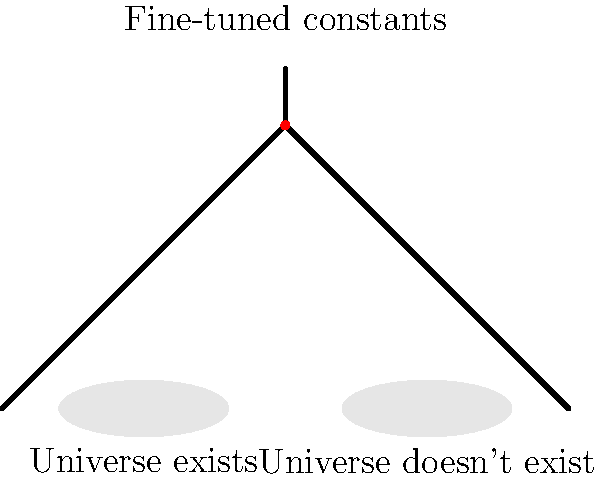In the context of the fine-tuning argument for the existence of a creator, what does the balance point in the cosmic scale represent, and how does it relate to the anthropic principle? To understand this question, let's break it down step-by-step:

1. The fine-tuning argument:
   This argument suggests that the fundamental physical constants of the universe are precisely set to allow for the existence of life. If these constants were slightly different, the universe as we know it wouldn't exist.

2. The cosmic balance scale:
   In the image, the balance scale represents the delicate nature of these physical constants. The left side represents a universe that can support life, while the right side represents a universe that cannot.

3. The balance point:
   The red dot at the fulcrum of the scale represents the exact values of physical constants that allow our universe to exist. This point symbolizes the precise "tuning" of these constants.

4. Relation to the anthropic principle:
   The anthropic principle states that we observe a universe capable of supporting life because we exist to observe it. This principle can be interpreted in two ways:
   a) Weak anthropic principle: Out of many possible universes, we naturally find ourselves in one that can support life.
   b) Strong anthropic principle: The universe is somehow compelled to have conditions that allow life to develop.

5. Creationist perspective:
   From a creationist viewpoint, the precise balance point could be seen as evidence of intelligent design. The fact that the constants are so finely tuned might suggest a creator who intentionally set these values to allow for life.

6. Scientific perspective:
   Scientists might argue that the apparent fine-tuning could be explained by the existence of multiple universes (multiverse theory) or by yet-undiscovered physical laws that necessitate these values.

The balance point in this cosmic scale, therefore, represents the precise values of physical constants that allow for our universe's existence, serving as a focal point for debates between creationist and scientific viewpoints on the origin and nature of the universe.
Answer: The balance point represents the precise values of fundamental physical constants that allow for the existence of our universe, relating to the anthropic principle by illustrating the apparent fine-tuning that enables life to exist and be observed. 